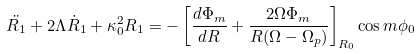<formula> <loc_0><loc_0><loc_500><loc_500>\ddot { R _ { 1 } } + 2 \Lambda \dot { R } _ { 1 } + \kappa _ { 0 } ^ { 2 } R _ { 1 } = - \left [ \frac { d \Phi _ { m } } { d R } + \frac { 2 \Omega \Phi _ { m } } { R ( \Omega - \Omega _ { p } ) } \right ] _ { R _ { 0 } } \cos m \phi _ { 0 }</formula> 